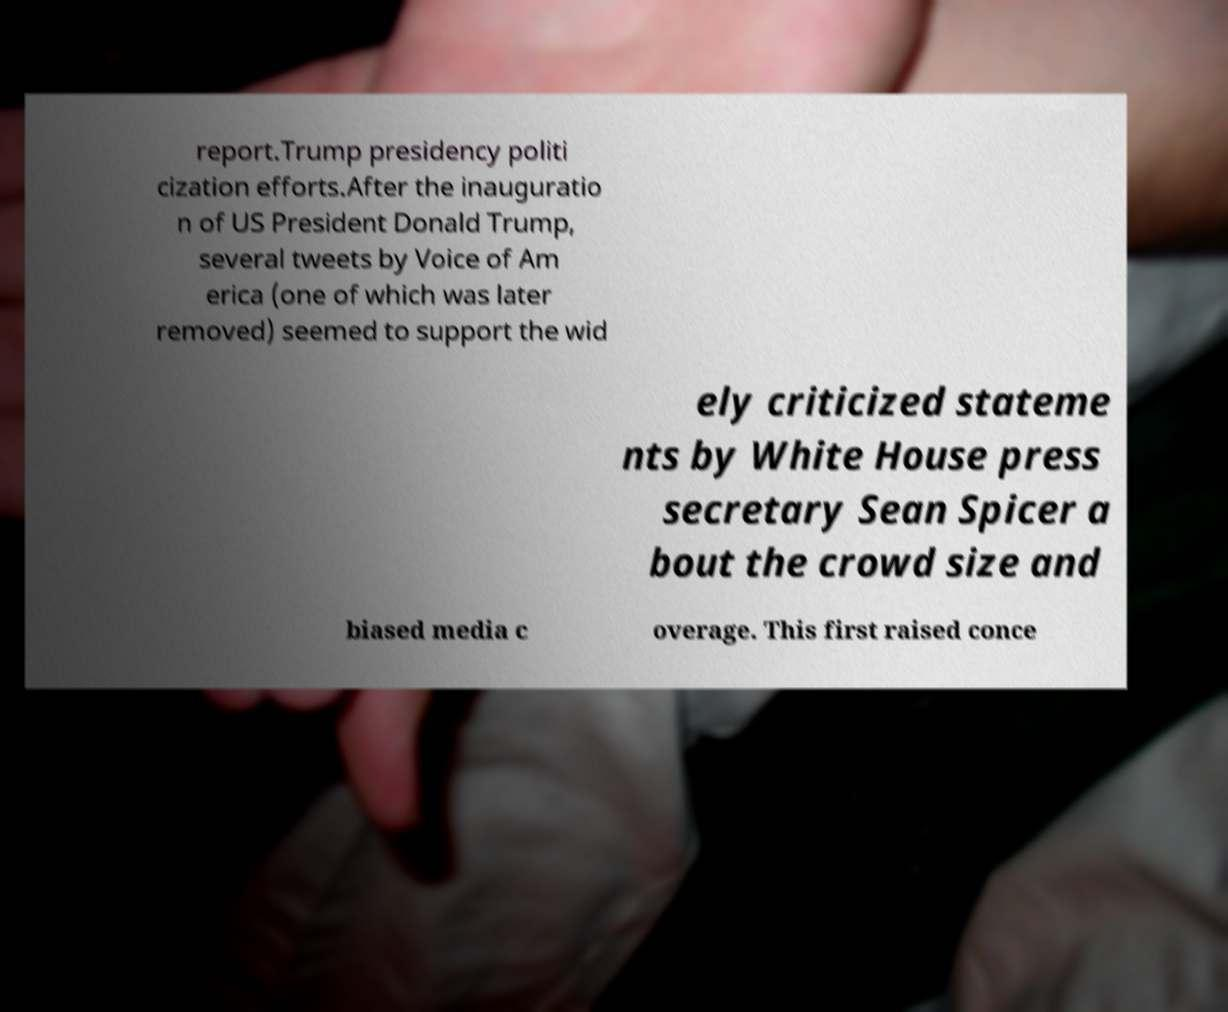Please read and relay the text visible in this image. What does it say? report.Trump presidency politi cization efforts.After the inauguratio n of US President Donald Trump, several tweets by Voice of Am erica (one of which was later removed) seemed to support the wid ely criticized stateme nts by White House press secretary Sean Spicer a bout the crowd size and biased media c overage. This first raised conce 